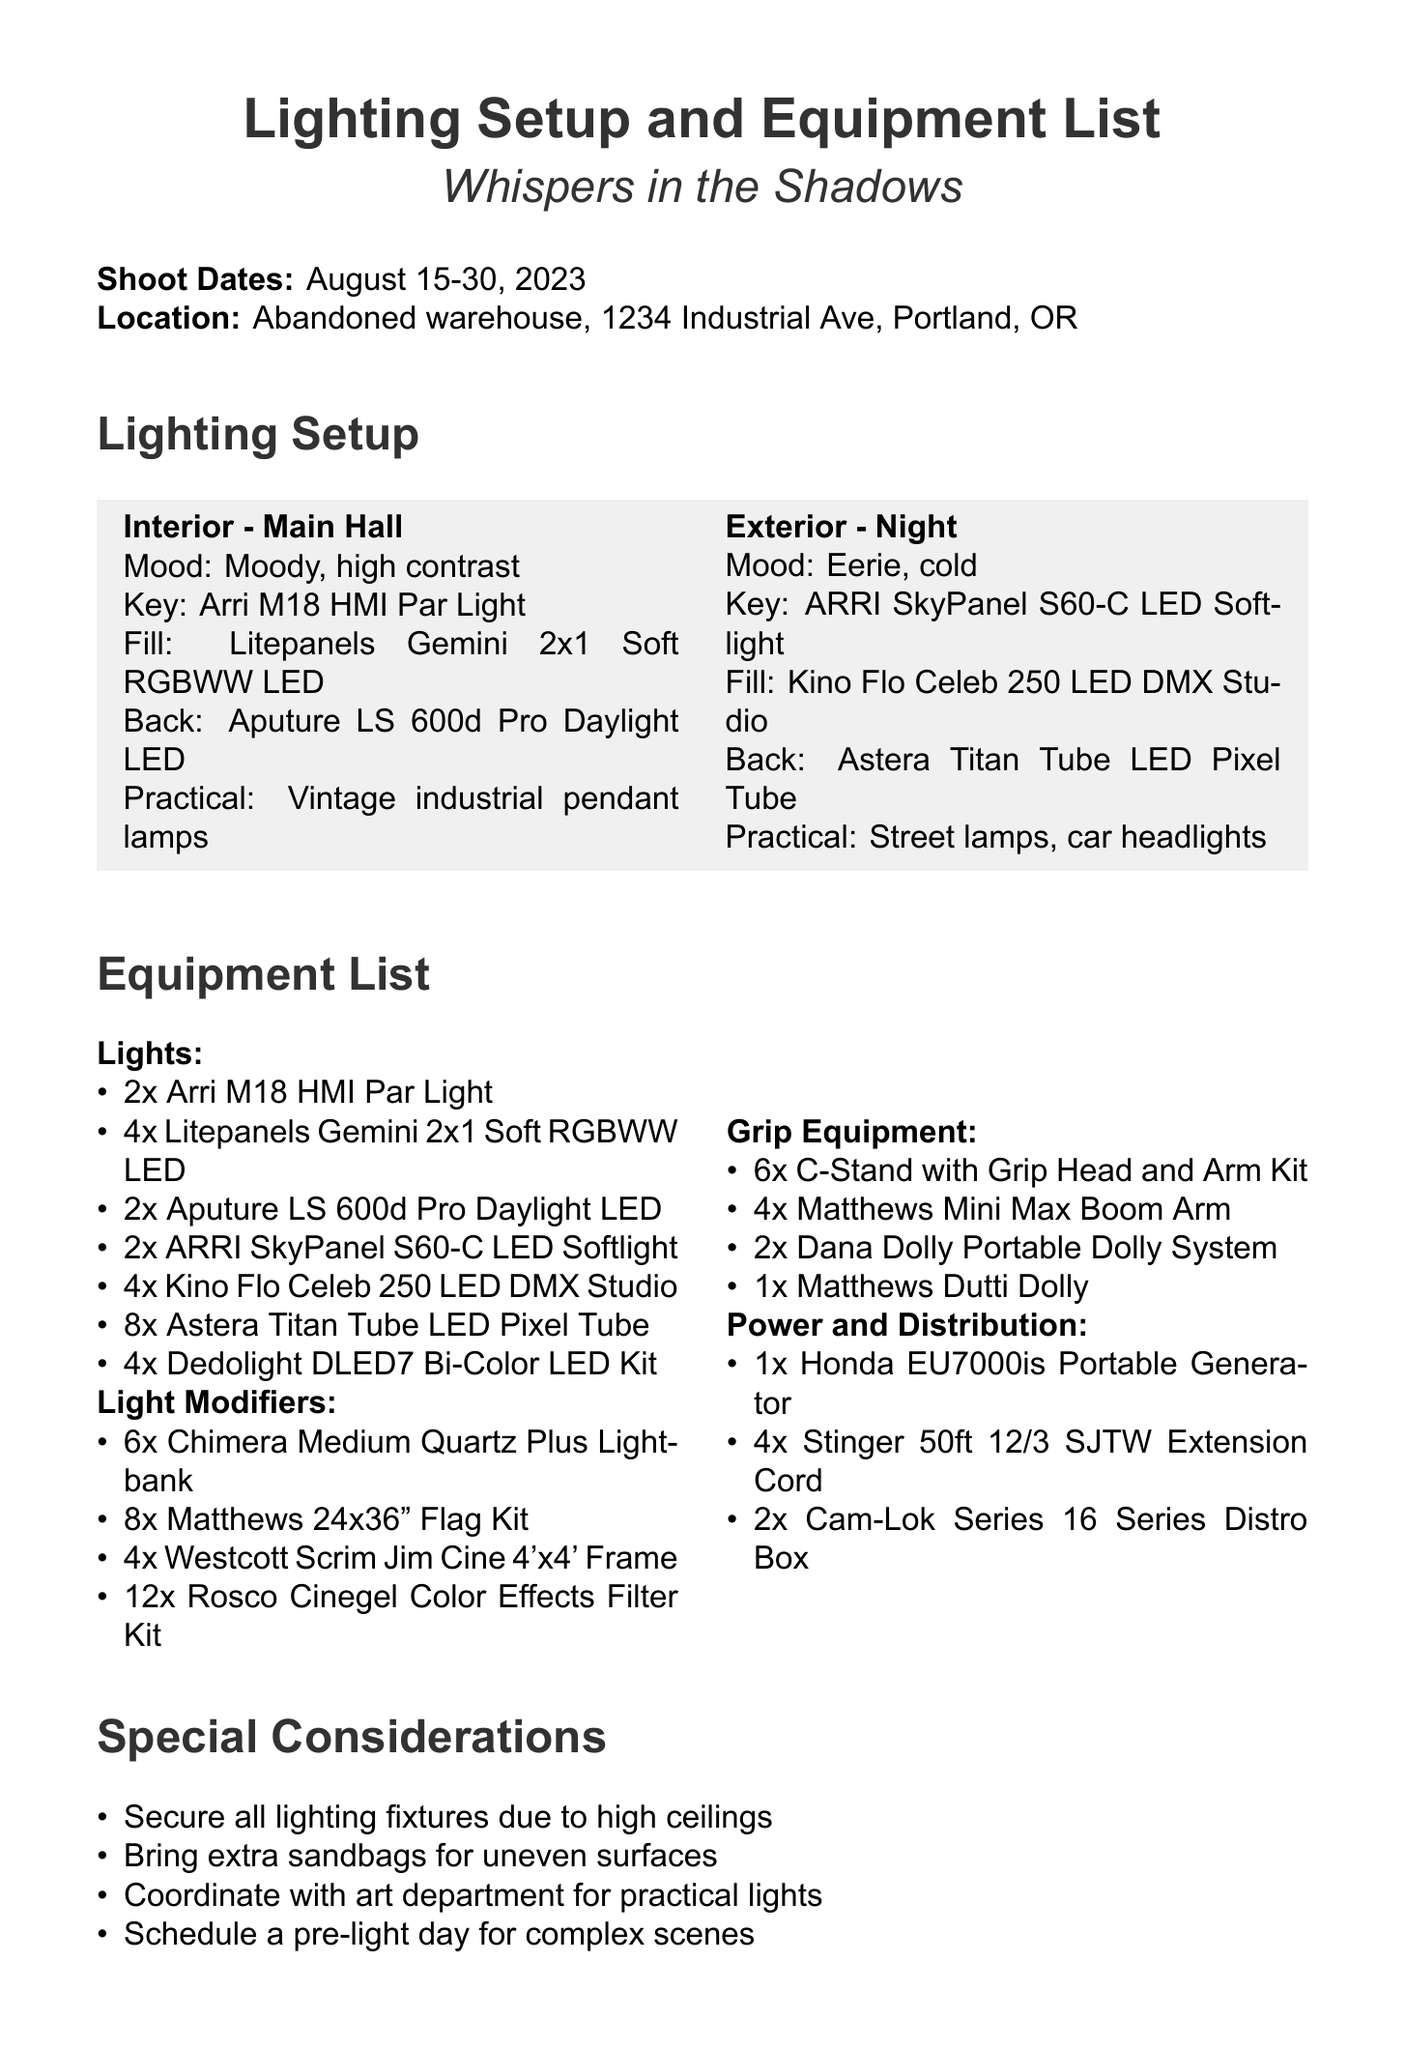What are the shoot dates? The shoot dates are clearly stated in the document as August 15-30, 2023.
Answer: August 15-30, 2023 What is the location of the shoot? The location of the shoot is specified as an abandoned warehouse at 1234 Industrial Ave, Portland, OR.
Answer: Abandoned warehouse, 1234 Industrial Ave, Portland, OR How many Arri M18 HMI Par Lights are listed in the equipment? The equipment list shows there are 2 Arri M18 HMI Par Lights included.
Answer: 2x Arri M18 HMI Par Light What is the budget allocation for lighting equipment rental? The budget allocation for lighting equipment rental is explicitly mentioned in the document as $15,000.
Answer: $15,000 Who is the gaffer for the project? The gaffer for the project is named as Sarah Thompson in the crew notes section.
Answer: Sarah Thompson What mood is associated with the "Interior - Main Hall" scene? The mood associated with the "Interior - Main Hall" scene is stated as moody, high contrast.
Answer: Moody, high contrast How many extra sandbags should be brought? The document doesn't specify a number for extra sandbags, it only states to bring extra sandbags for stabilizing.
Answer: Extra sandbags What type of portable generator is listed in the power and distribution category? The type of portable generator mentioned is the Honda EU7000is.
Answer: Honda EU7000is Portable Generator 